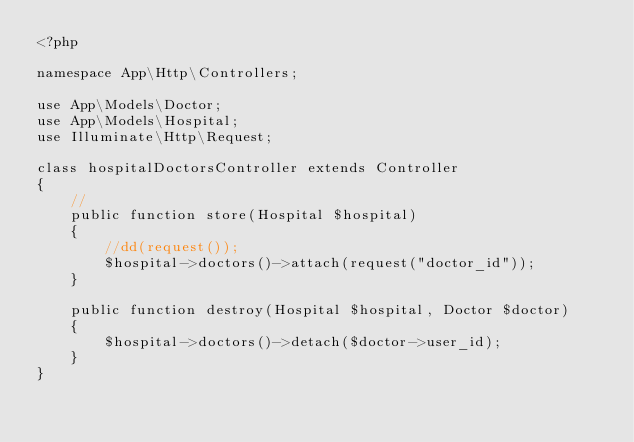<code> <loc_0><loc_0><loc_500><loc_500><_PHP_><?php

namespace App\Http\Controllers;

use App\Models\Doctor;
use App\Models\Hospital;
use Illuminate\Http\Request;

class hospitalDoctorsController extends Controller
{
    //
    public function store(Hospital $hospital)
    {
        //dd(request());
        $hospital->doctors()->attach(request("doctor_id"));    
    }

    public function destroy(Hospital $hospital, Doctor $doctor)
    {
        $hospital->doctors()->detach($doctor->user_id);    
    }
}
</code> 